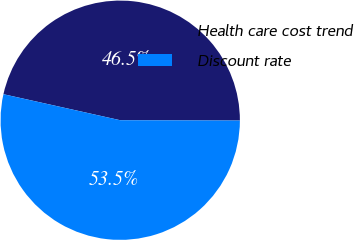Convert chart. <chart><loc_0><loc_0><loc_500><loc_500><pie_chart><fcel>Health care cost trend<fcel>Discount rate<nl><fcel>46.55%<fcel>53.45%<nl></chart> 